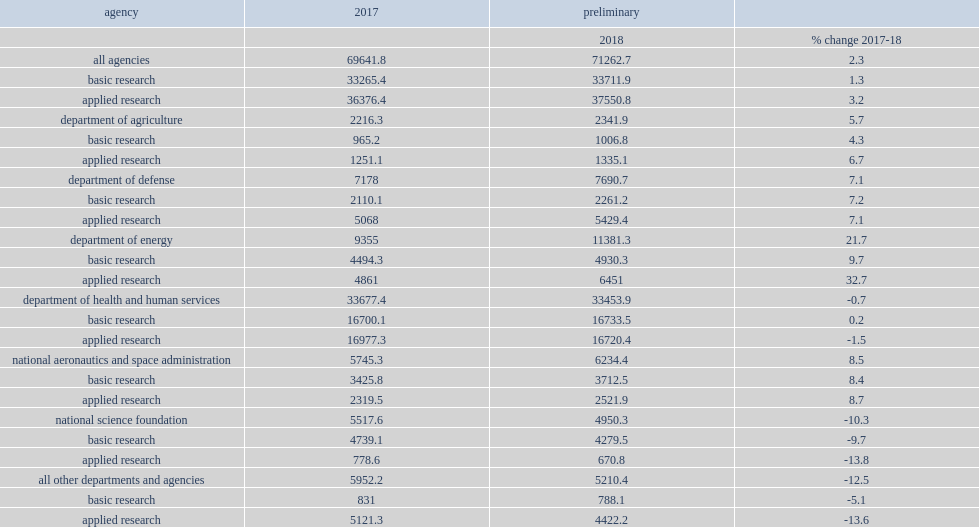Which agency accounted for the largest share of federal research obligations? Department of health and human services. The department of health and human services (hhs), which includes the national institutes of health, accounted for the largest share (46.9%) of federal research obligations, how many million dollars in fy 2018? 33453.9. How many percent did the department of energy (doe) accounte of fy 2018 research total? 0.159709. How many percent did the department of defense (dod) accounte of fy 2018 research total? 0.10792. How many percent did the national aeronautics and space administration (nasa) account of fy 2018 research total? 0.087485. How many percent did the national science foundation(nsf) account of fy 2018 research total? 0.069466. How many percent did the department of agriculture (usda) account of fy 2018 research total? 0.032863. 